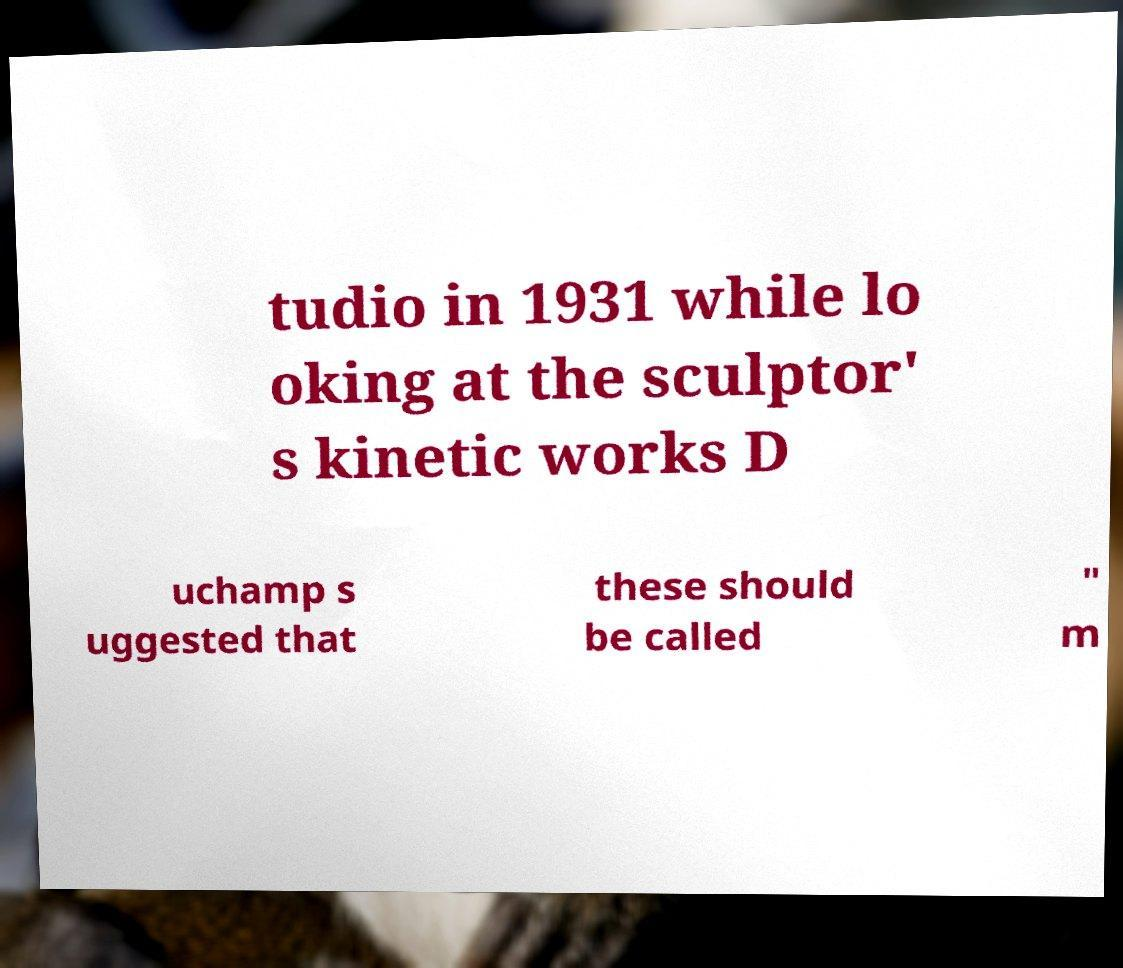There's text embedded in this image that I need extracted. Can you transcribe it verbatim? tudio in 1931 while lo oking at the sculptor' s kinetic works D uchamp s uggested that these should be called " m 